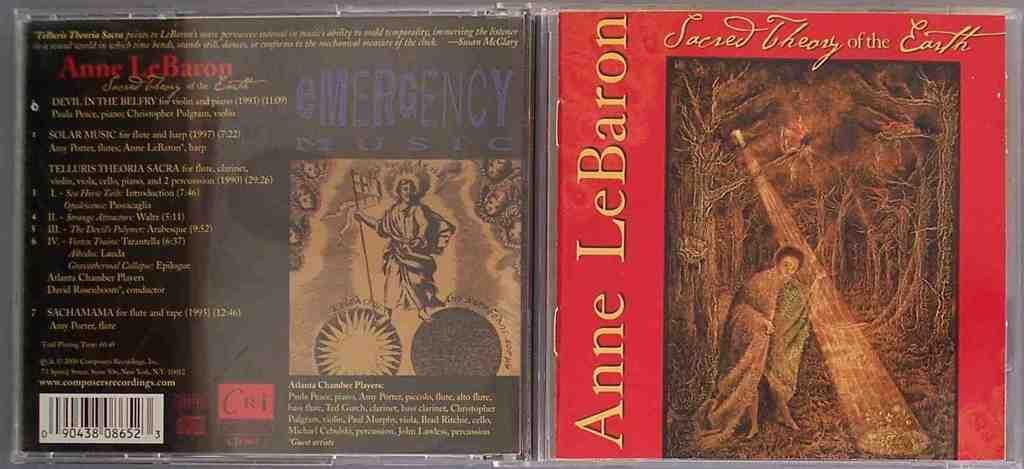<image>
Write a terse but informative summary of the picture. the case for the Anne Lebaron musical album. 